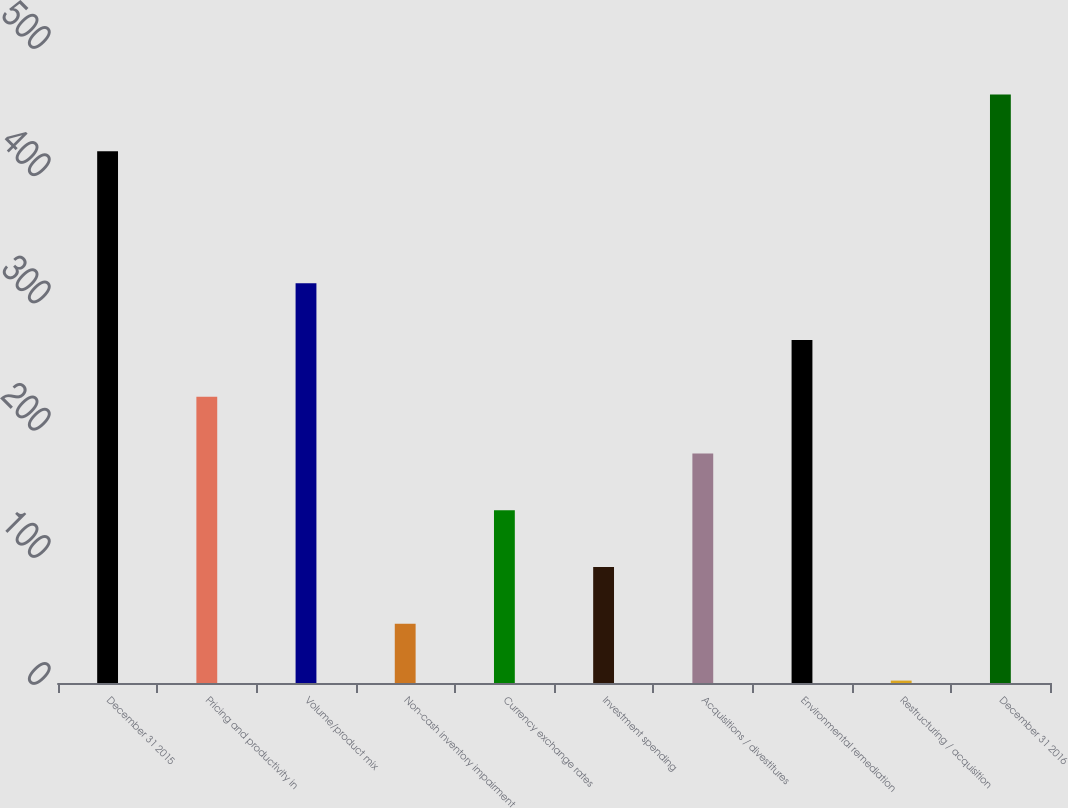Convert chart to OTSL. <chart><loc_0><loc_0><loc_500><loc_500><bar_chart><fcel>December 31 2015<fcel>Pricing and productivity in<fcel>Volume/product mix<fcel>Non-cash inventory impairment<fcel>Currency exchange rates<fcel>Investment spending<fcel>Acquisitions / divestitures<fcel>Environmental remediation<fcel>Restructuring / acquisition<fcel>December 31 2016<nl><fcel>418<fcel>225<fcel>314.24<fcel>46.52<fcel>135.76<fcel>91.14<fcel>180.38<fcel>269.62<fcel>1.9<fcel>462.62<nl></chart> 